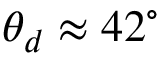Convert formula to latex. <formula><loc_0><loc_0><loc_500><loc_500>\theta _ { d } \approx 4 2 ^ { \circ }</formula> 